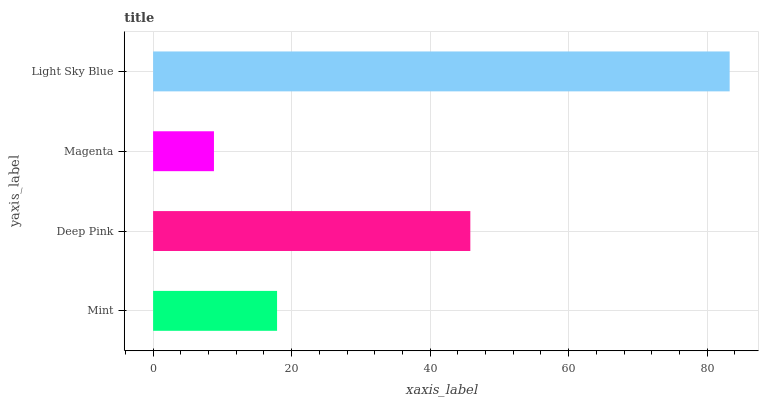Is Magenta the minimum?
Answer yes or no. Yes. Is Light Sky Blue the maximum?
Answer yes or no. Yes. Is Deep Pink the minimum?
Answer yes or no. No. Is Deep Pink the maximum?
Answer yes or no. No. Is Deep Pink greater than Mint?
Answer yes or no. Yes. Is Mint less than Deep Pink?
Answer yes or no. Yes. Is Mint greater than Deep Pink?
Answer yes or no. No. Is Deep Pink less than Mint?
Answer yes or no. No. Is Deep Pink the high median?
Answer yes or no. Yes. Is Mint the low median?
Answer yes or no. Yes. Is Magenta the high median?
Answer yes or no. No. Is Light Sky Blue the low median?
Answer yes or no. No. 